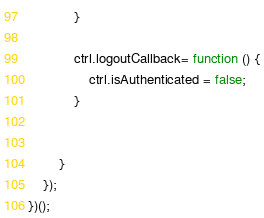<code> <loc_0><loc_0><loc_500><loc_500><_JavaScript_>            }

            ctrl.logoutCallback= function () {
                ctrl.isAuthenticated = false;
            }


        }
    });
})();</code> 